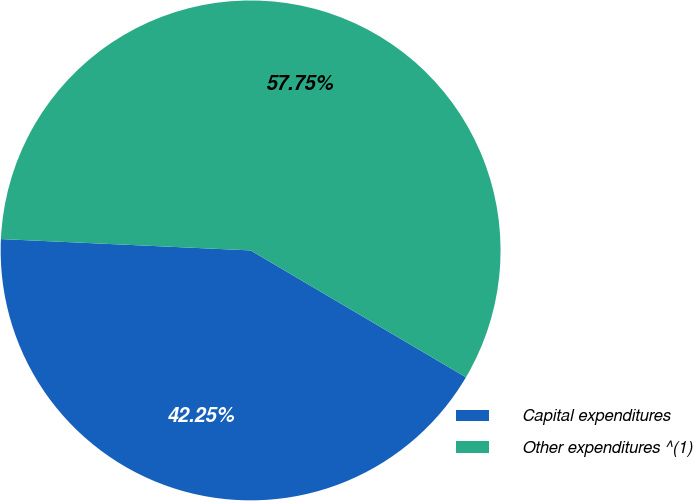<chart> <loc_0><loc_0><loc_500><loc_500><pie_chart><fcel>Capital expenditures<fcel>Other expenditures ^(1)<nl><fcel>42.25%<fcel>57.75%<nl></chart> 